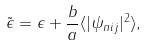Convert formula to latex. <formula><loc_0><loc_0><loc_500><loc_500>\tilde { \epsilon } = \epsilon + \frac { b } { a } \langle | \psi _ { n i j } | ^ { 2 } \rangle ,</formula> 